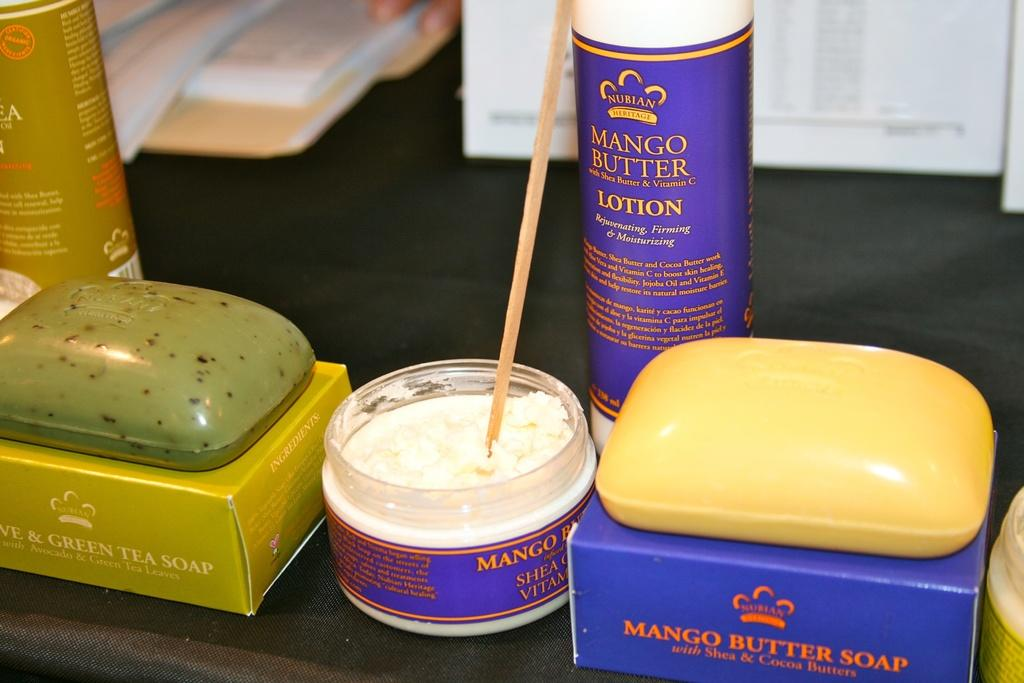<image>
Present a compact description of the photo's key features. Several  personal care items involving mango are on the table. 